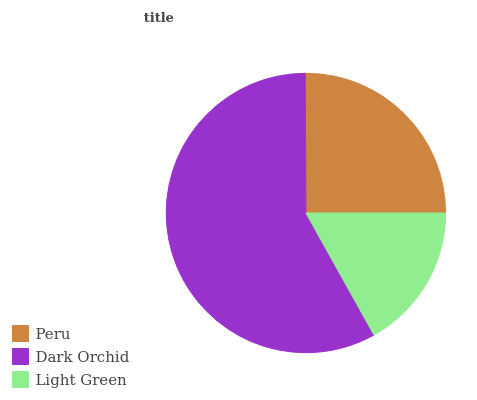Is Light Green the minimum?
Answer yes or no. Yes. Is Dark Orchid the maximum?
Answer yes or no. Yes. Is Dark Orchid the minimum?
Answer yes or no. No. Is Light Green the maximum?
Answer yes or no. No. Is Dark Orchid greater than Light Green?
Answer yes or no. Yes. Is Light Green less than Dark Orchid?
Answer yes or no. Yes. Is Light Green greater than Dark Orchid?
Answer yes or no. No. Is Dark Orchid less than Light Green?
Answer yes or no. No. Is Peru the high median?
Answer yes or no. Yes. Is Peru the low median?
Answer yes or no. Yes. Is Dark Orchid the high median?
Answer yes or no. No. Is Dark Orchid the low median?
Answer yes or no. No. 